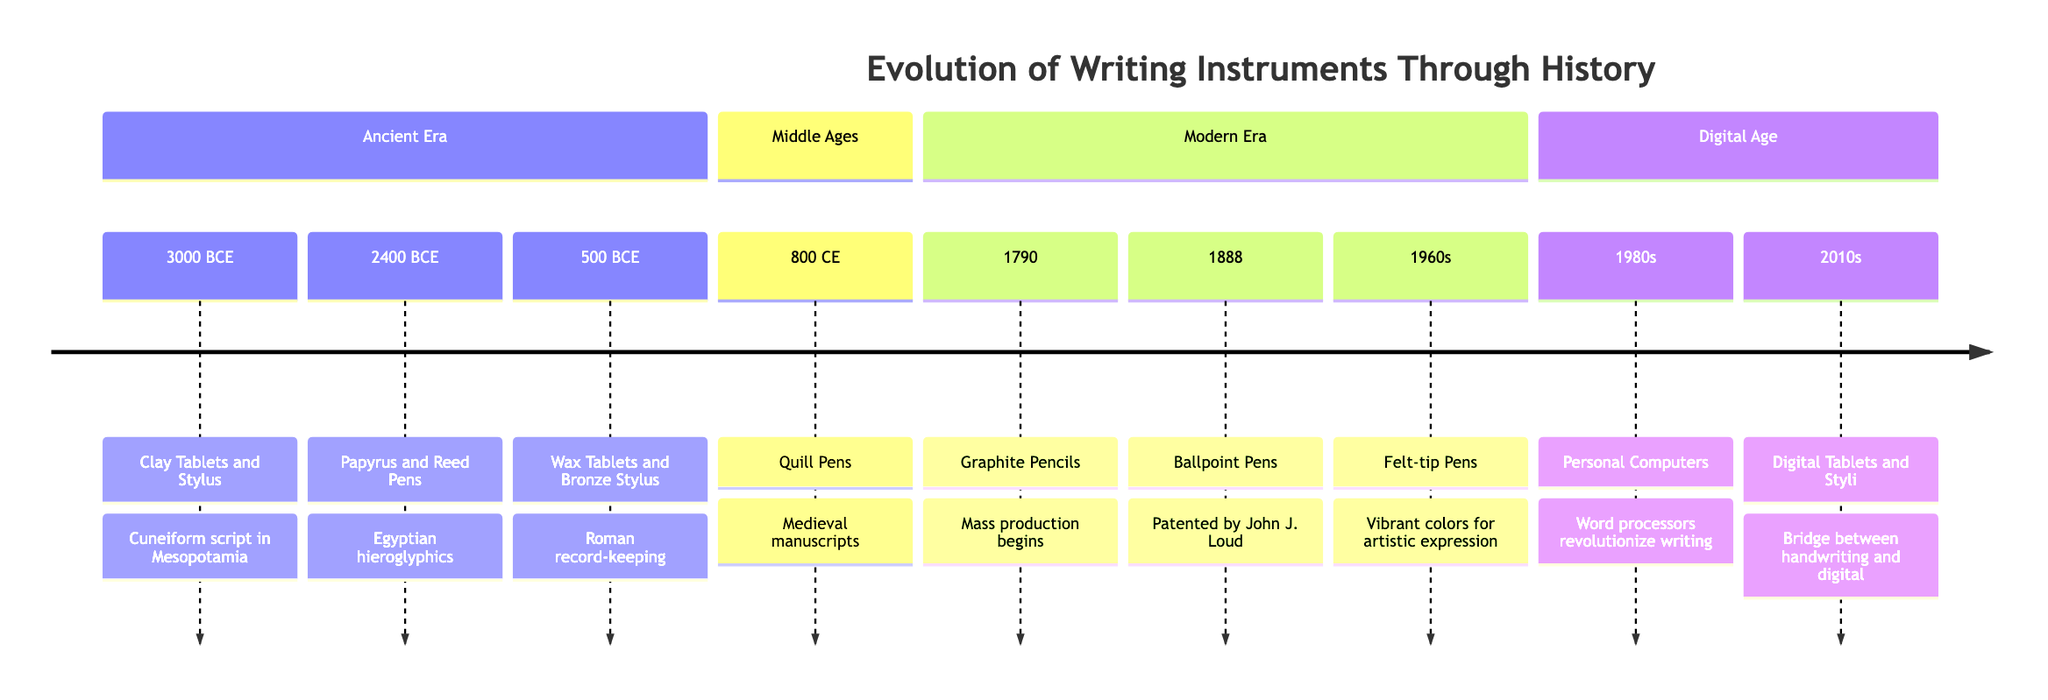What writing instrument was used in 3000 BCE? The timeline specifies that the instrument used in 3000 BCE was "Clay Tablets and Stylus." This is directly mentioned in the section for the Ancient Era under that year.
Answer: Clay Tablets and Stylus Which instrument was patented in 1888? The item listed for 1888 on the timeline is "Ballpoint Pens," which indicates that this was the year it was patented by John J. Loud.
Answer: Ballpoint Pens How many writing instruments are mentioned in the Middle Ages section? In the Middle Ages section, there is one entry, which corresponds to "Quill Pens" in 800 CE. This can be counted directly from that section.
Answer: 1 What impact did the advent of personal computers in the 1980s have on writing? The impact of personal computers and word processors during the 1980s, as stated in the timeline, was a "revolution in writing," indicating a significant change in writing and editing processes.
Answer: Revolution Which writing instrument introduced fine lines in the Medieval era? The writing instrument that provided finer lines during the Medieval era is explicitly stated to be "Quill Pens," which are noted for their control and line quality.
Answer: Quill Pens What era did the use of Graphite Pencils begin? The timeline states that the mass production of Graphite Pencils began in the year "1790," making it clear which era this innovation is from.
Answer: 1790 Which writing instrument dominated the 1960s for artistic expression? The timeline mentions "Felt-tip Pens" as the instrument that brought vibrant colors to writing in the 1960s, thus indicating its significance during that time for artistic purposes.
Answer: Felt-tip Pens How did writing evolve from wax tablets to modern instruments? The transition from wax tablets, used by Romans, to modern instruments like digital tablets and styli reflects a technological advancement in writing. The reasoning involves acknowledging each successive entry on the timeline that marks a shift in writing technology over centuries.
Answer: Technological advancement What is the main impact of digital tablets and styli according to the timeline? The timeline indicates that digital tablets and styli create a "bridge between handwriting and digital," highlighting their role in blending traditional and modern writing methods.
Answer: Bridge between handwriting and digital 